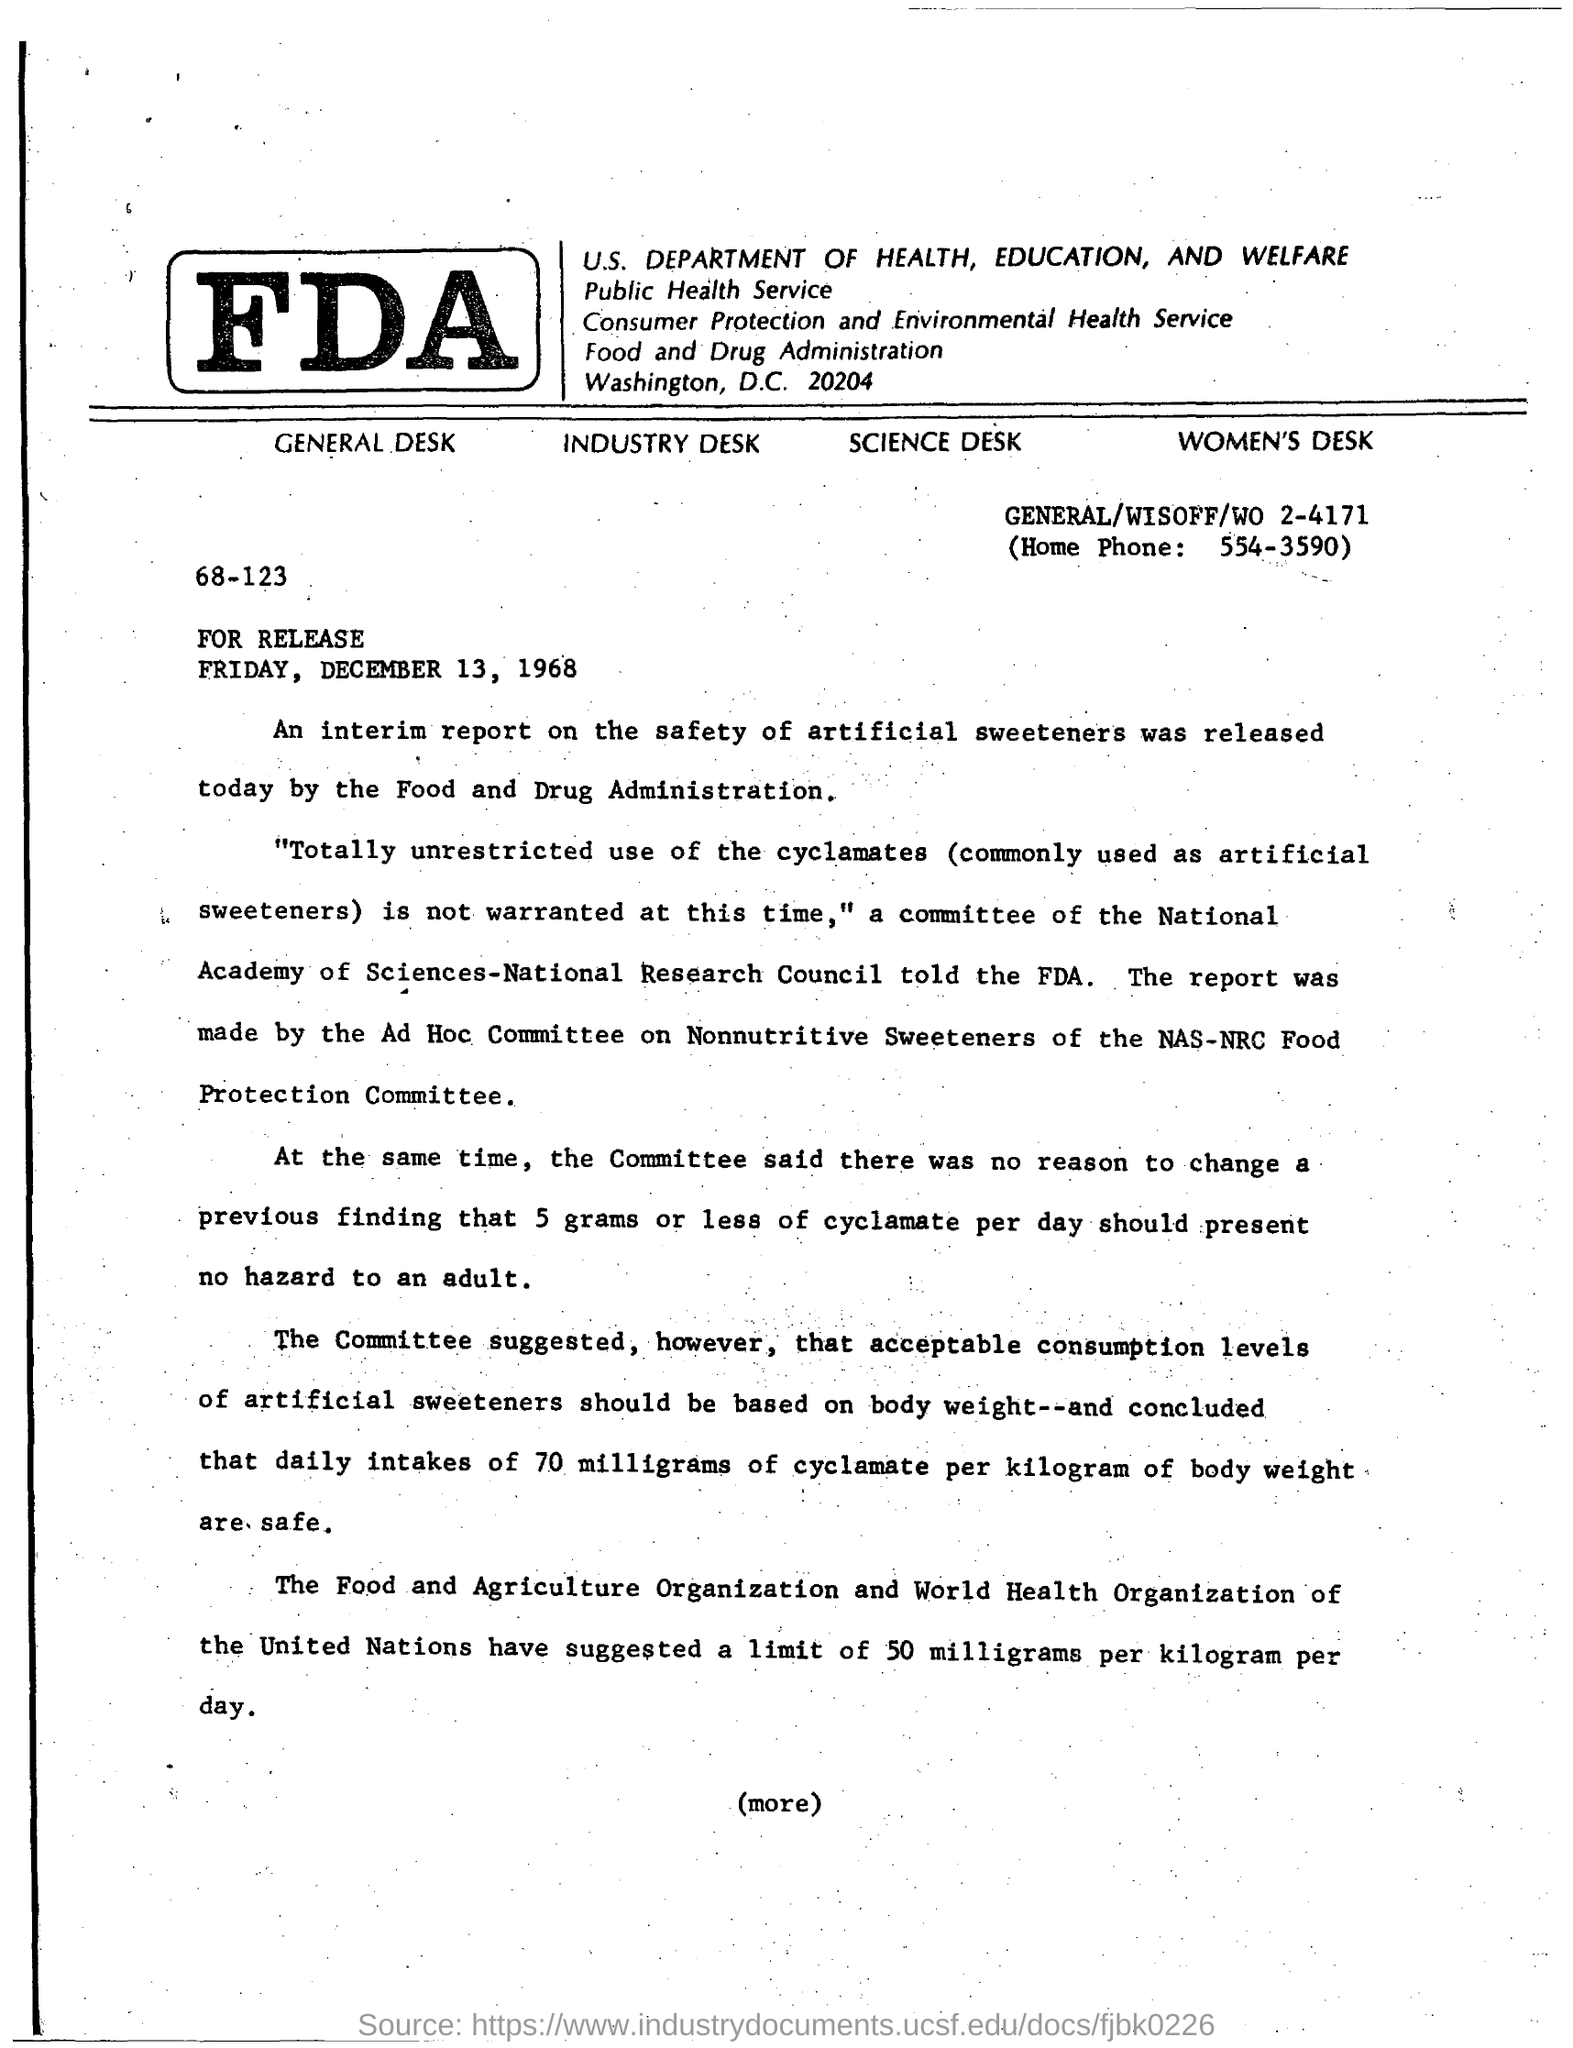What is the Home Phone?
Offer a terse response. 554-3590. 